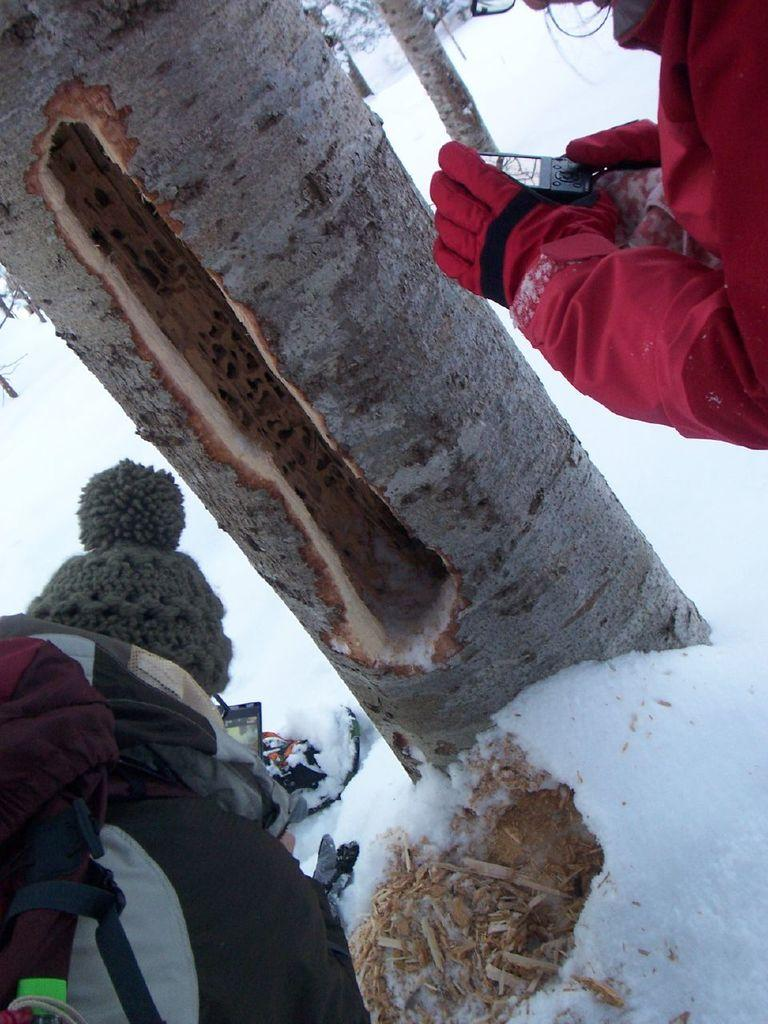What is the main subject of the image? The main subjects of the image are two people standing in the snow. What is the person on the left holding in their hand? The person on the left is holding a mobile in their hand. What is the person on the right wearing on their head? The person on the right is wearing a woolen cap. What is the person on the right carrying? The person on the right is carrying a bag. What can be seen on the tree bark in the image? There is no tree bark visible in the image. What type of metal can be seen on the plants in the image? There are no plants or metal present in the image. 